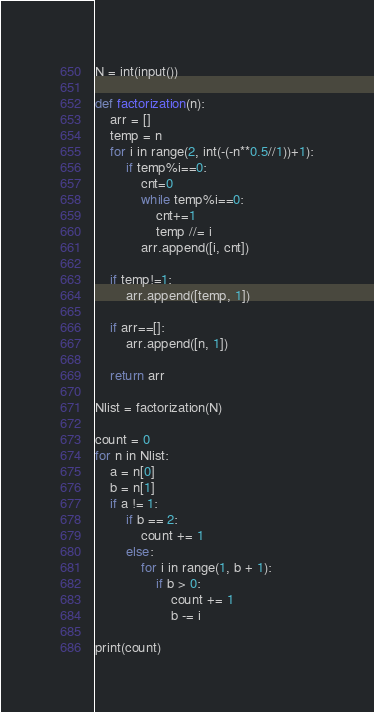<code> <loc_0><loc_0><loc_500><loc_500><_Python_>N = int(input())

def factorization(n):
    arr = []
    temp = n
    for i in range(2, int(-(-n**0.5//1))+1):
        if temp%i==0:
            cnt=0
            while temp%i==0:
                cnt+=1
                temp //= i
            arr.append([i, cnt])

    if temp!=1:
        arr.append([temp, 1])

    if arr==[]:
        arr.append([n, 1])

    return arr

Nlist = factorization(N)

count = 0
for n in Nlist:
    a = n[0]
    b = n[1]
    if a != 1:
        if b == 2:
            count += 1
        else:
            for i in range(1, b + 1):
                if b > 0:
                    count += 1
                    b -= i

print(count)</code> 